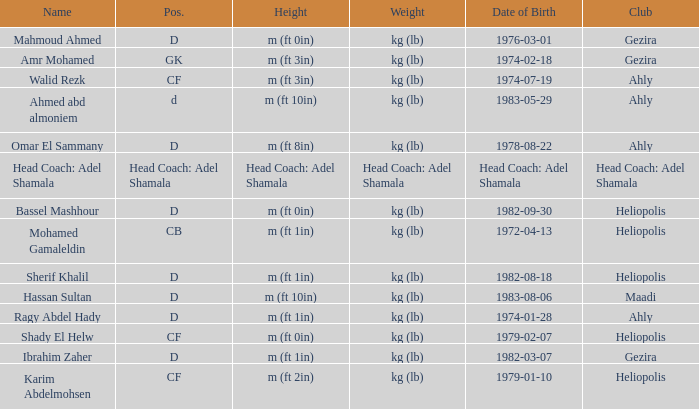What is Weight, when Club is "Ahly", and when Name is "Ragy Abdel Hady"? Kg (lb). Would you be able to parse every entry in this table? {'header': ['Name', 'Pos.', 'Height', 'Weight', 'Date of Birth', 'Club'], 'rows': [['Mahmoud Ahmed', 'D', 'm (ft 0in)', 'kg (lb)', '1976-03-01', 'Gezira'], ['Amr Mohamed', 'GK', 'm (ft 3in)', 'kg (lb)', '1974-02-18', 'Gezira'], ['Walid Rezk', 'CF', 'm (ft 3in)', 'kg (lb)', '1974-07-19', 'Ahly'], ['Ahmed abd almoniem', 'd', 'm (ft 10in)', 'kg (lb)', '1983-05-29', 'Ahly'], ['Omar El Sammany', 'D', 'm (ft 8in)', 'kg (lb)', '1978-08-22', 'Ahly'], ['Head Coach: Adel Shamala', 'Head Coach: Adel Shamala', 'Head Coach: Adel Shamala', 'Head Coach: Adel Shamala', 'Head Coach: Adel Shamala', 'Head Coach: Adel Shamala'], ['Bassel Mashhour', 'D', 'm (ft 0in)', 'kg (lb)', '1982-09-30', 'Heliopolis'], ['Mohamed Gamaleldin', 'CB', 'm (ft 1in)', 'kg (lb)', '1972-04-13', 'Heliopolis'], ['Sherif Khalil', 'D', 'm (ft 1in)', 'kg (lb)', '1982-08-18', 'Heliopolis'], ['Hassan Sultan', 'D', 'm (ft 10in)', 'kg (lb)', '1983-08-06', 'Maadi'], ['Ragy Abdel Hady', 'D', 'm (ft 1in)', 'kg (lb)', '1974-01-28', 'Ahly'], ['Shady El Helw', 'CF', 'm (ft 0in)', 'kg (lb)', '1979-02-07', 'Heliopolis'], ['Ibrahim Zaher', 'D', 'm (ft 1in)', 'kg (lb)', '1982-03-07', 'Gezira'], ['Karim Abdelmohsen', 'CF', 'm (ft 2in)', 'kg (lb)', '1979-01-10', 'Heliopolis']]} 